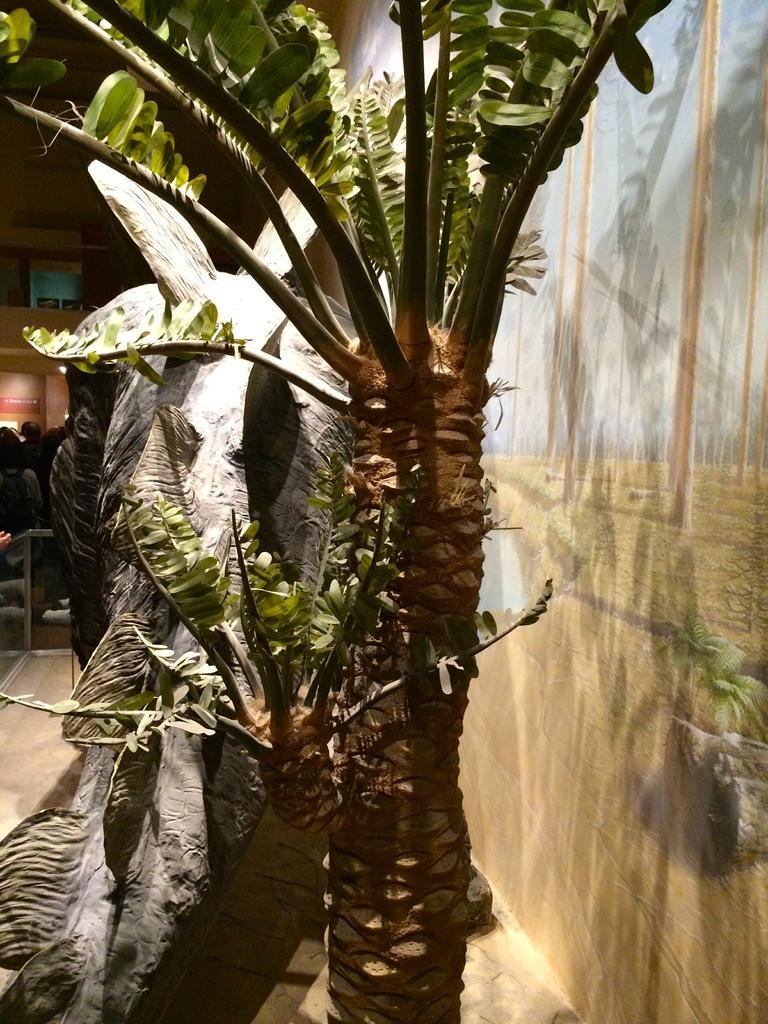How would you summarize this image in a sentence or two? Painting is on the wall. Beside this painting wall there is a tree. Far there are people. 